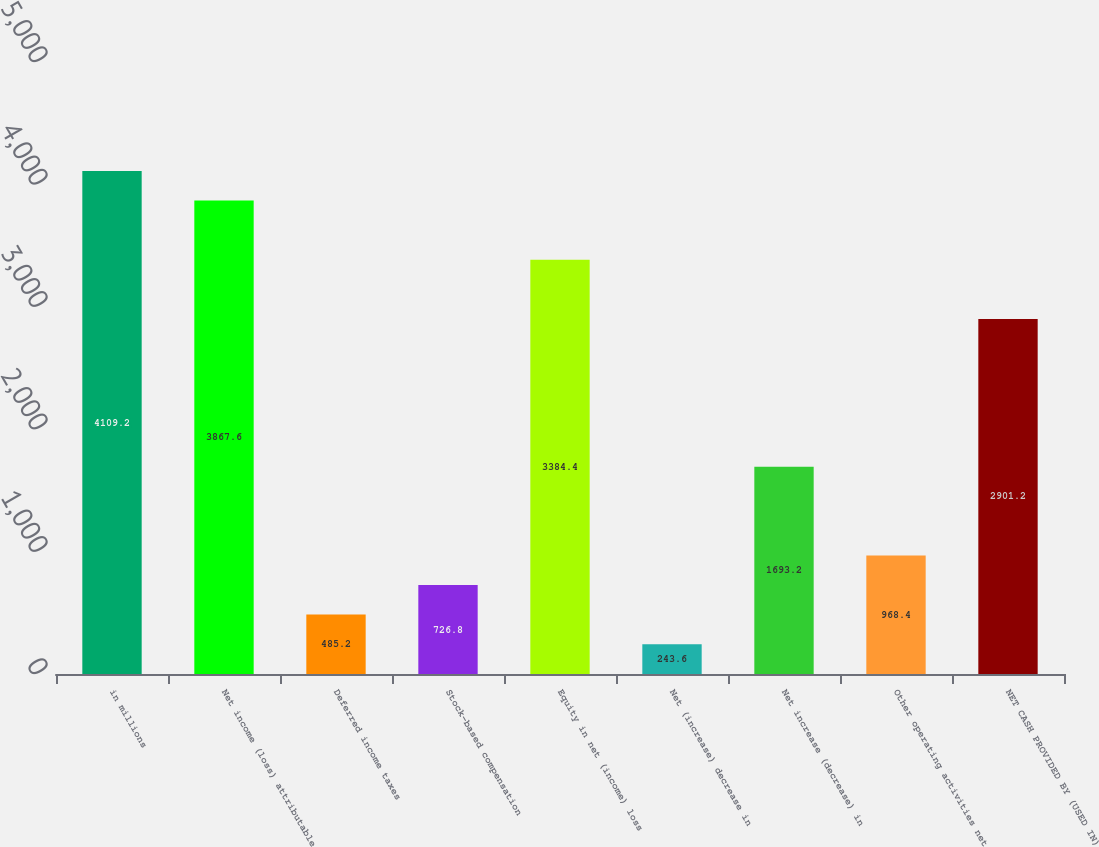Convert chart. <chart><loc_0><loc_0><loc_500><loc_500><bar_chart><fcel>in millions<fcel>Net income (loss) attributable<fcel>Deferred income taxes<fcel>Stock-based compensation<fcel>Equity in net (income) loss<fcel>Net (increase) decrease in<fcel>Net increase (decrease) in<fcel>Other operating activities net<fcel>NET CASH PROVIDED BY (USED IN)<nl><fcel>4109.2<fcel>3867.6<fcel>485.2<fcel>726.8<fcel>3384.4<fcel>243.6<fcel>1693.2<fcel>968.4<fcel>2901.2<nl></chart> 